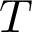<formula> <loc_0><loc_0><loc_500><loc_500>T</formula> 